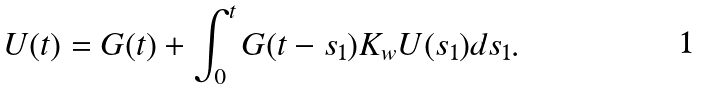<formula> <loc_0><loc_0><loc_500><loc_500>U ( t ) = G ( t ) + \int _ { 0 } ^ { t } G ( t - s _ { 1 } ) K _ { w } U ( s _ { 1 } ) d s _ { 1 } .</formula> 